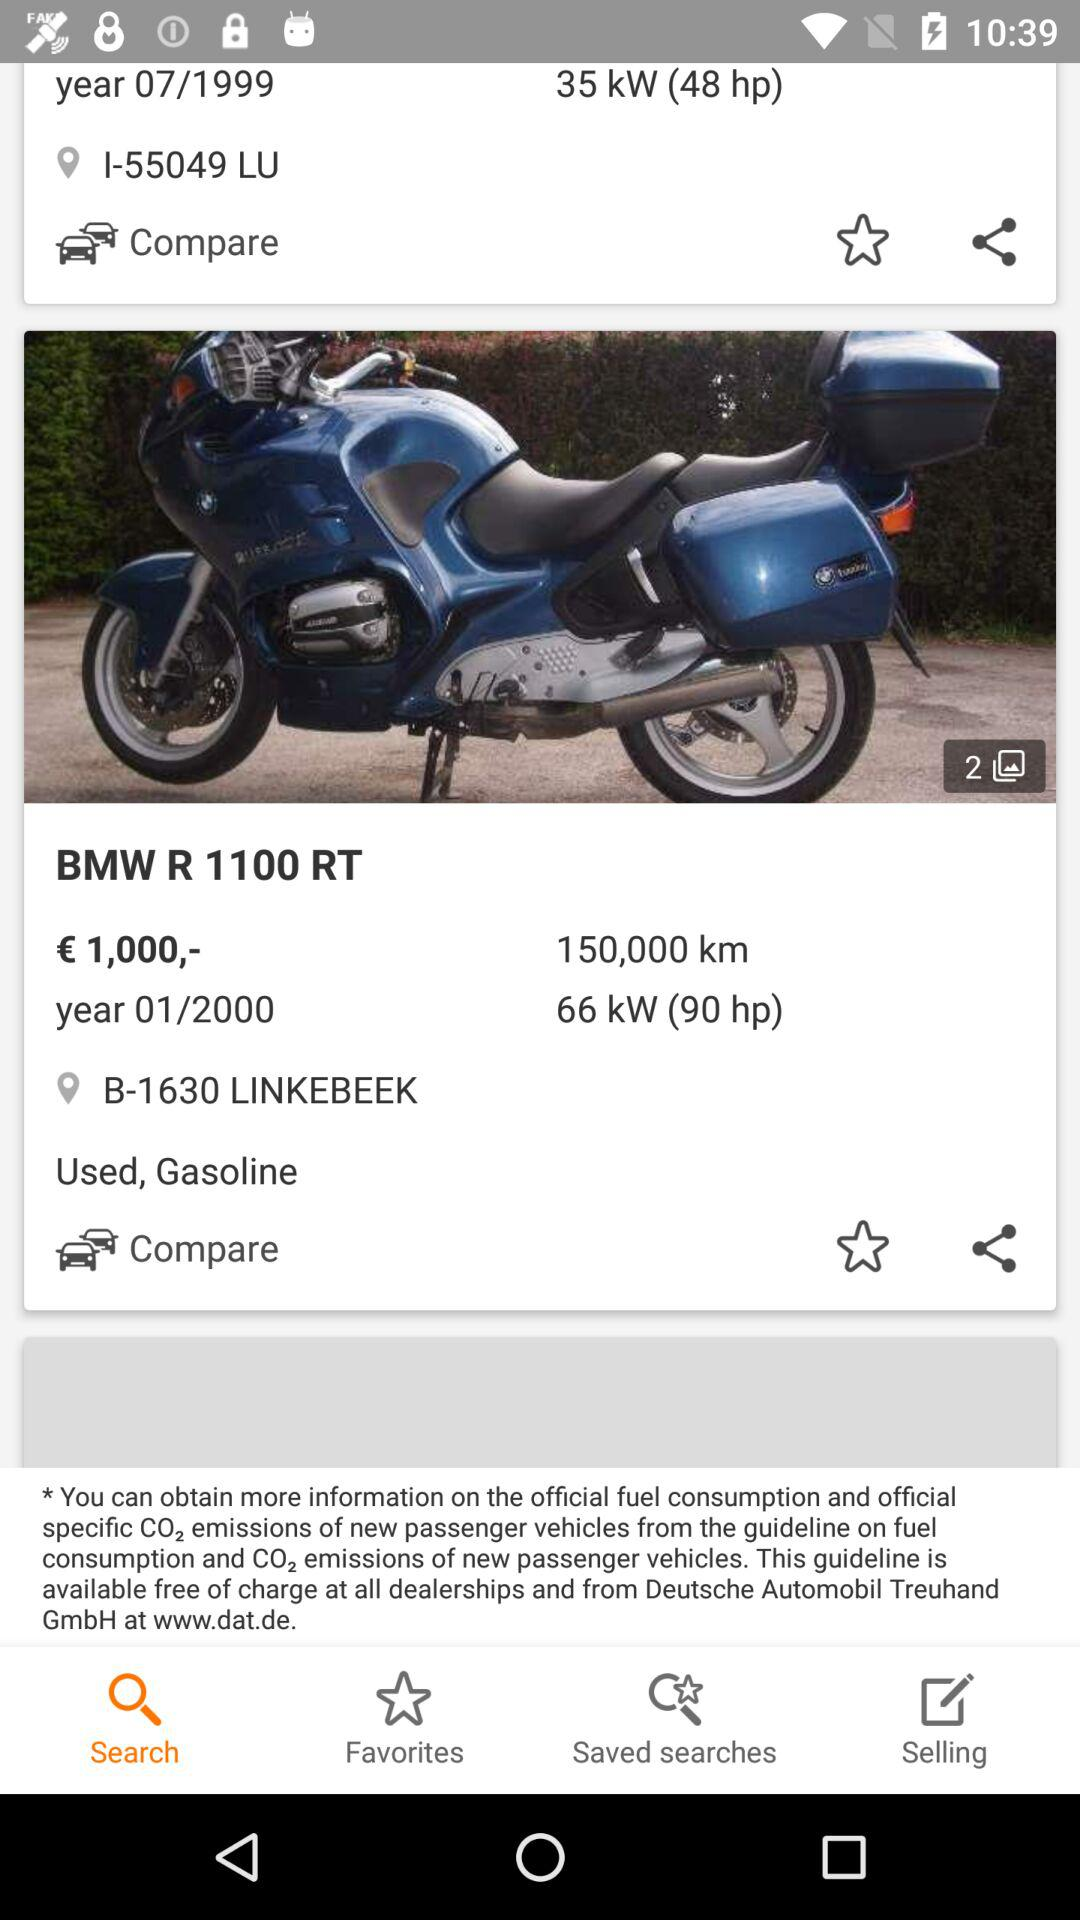What is the horsepower? The horsepower is 90. 